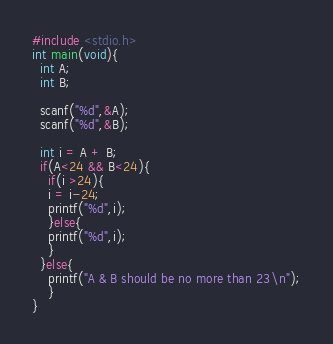<code> <loc_0><loc_0><loc_500><loc_500><_C_>#include <stdio.h>
int main(void){
  int A;
  int B;

  scanf("%d",&A);
  scanf("%d",&B);
  
  int i = A + B;
  if(A<24 && B<24){
    if(i >24){
    i = i-24;
    printf("%d",i);
    }else{
    printf("%d",i);
    }
  }else{
    printf("A & B should be no more than 23\n");
    }
}</code> 